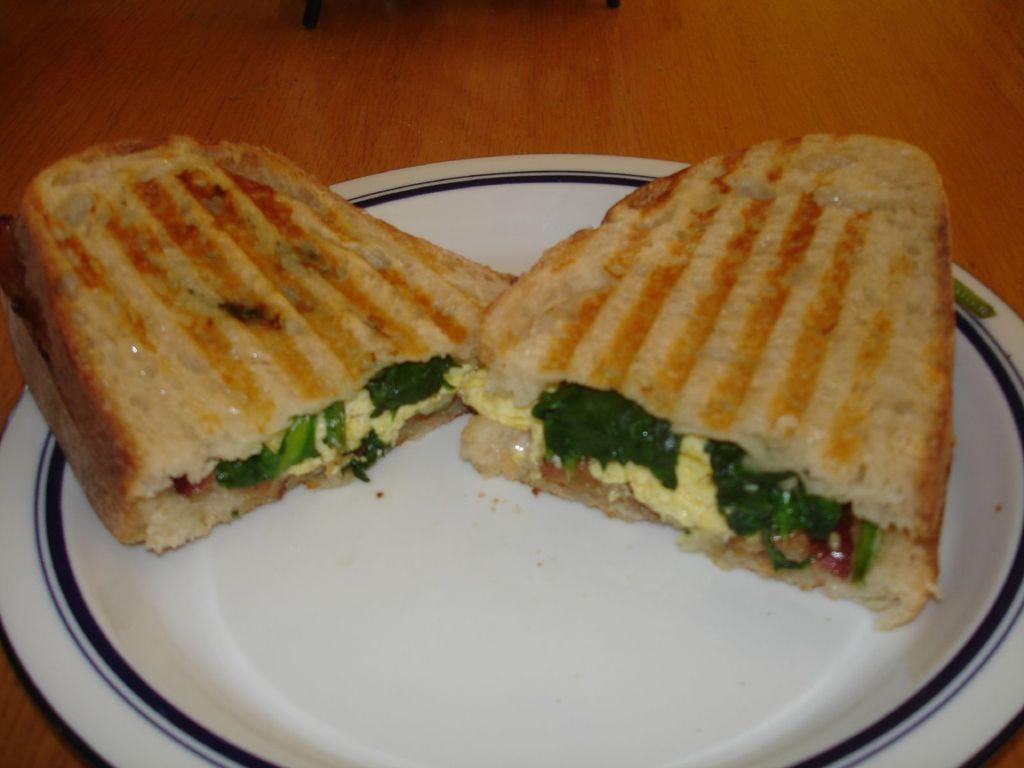What is on the plate that is visible in the image? The plate contains two slices of sandwich in the image. What type of surface is the plate resting on? The wooden table is present in the image. How many feet are visible on the plate in the image? There are no feet visible on the plate in the image; it contains two slices of sandwich. 